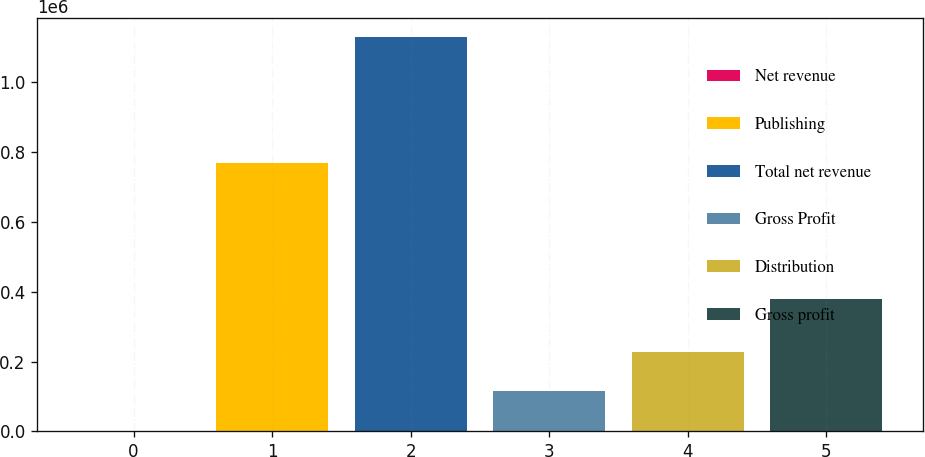Convert chart to OTSL. <chart><loc_0><loc_0><loc_500><loc_500><bar_chart><fcel>Net revenue<fcel>Publishing<fcel>Total net revenue<fcel>Gross Profit<fcel>Distribution<fcel>Gross profit<nl><fcel>2004<fcel>768482<fcel>1.12775e+06<fcel>114579<fcel>227153<fcel>378071<nl></chart> 